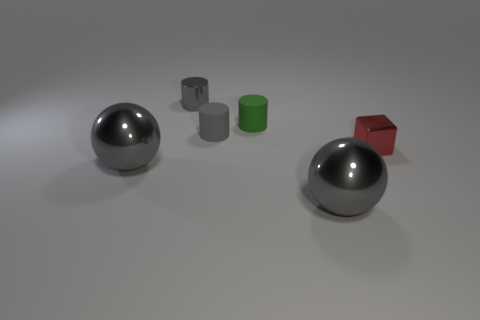There is a matte thing that is the same color as the small metal cylinder; what size is it?
Provide a short and direct response. Small. What number of spheres are either shiny objects or tiny gray things?
Give a very brief answer. 2. The other thing that is the same material as the green thing is what size?
Ensure brevity in your answer.  Small. There is a matte object to the left of the green rubber cylinder; does it have the same size as the gray metal object behind the red thing?
Your response must be concise. Yes. How many things are small purple objects or red blocks?
Your answer should be compact. 1. The green object is what shape?
Keep it short and to the point. Cylinder. There is another rubber thing that is the same shape as the tiny gray matte object; what size is it?
Your answer should be very brief. Small. Is there anything else that is made of the same material as the green object?
Your response must be concise. Yes. How big is the object in front of the big shiny ball that is on the left side of the green matte cylinder?
Provide a short and direct response. Large. Are there the same number of big gray shiny objects right of the small red object and metal cubes?
Provide a succinct answer. No. 